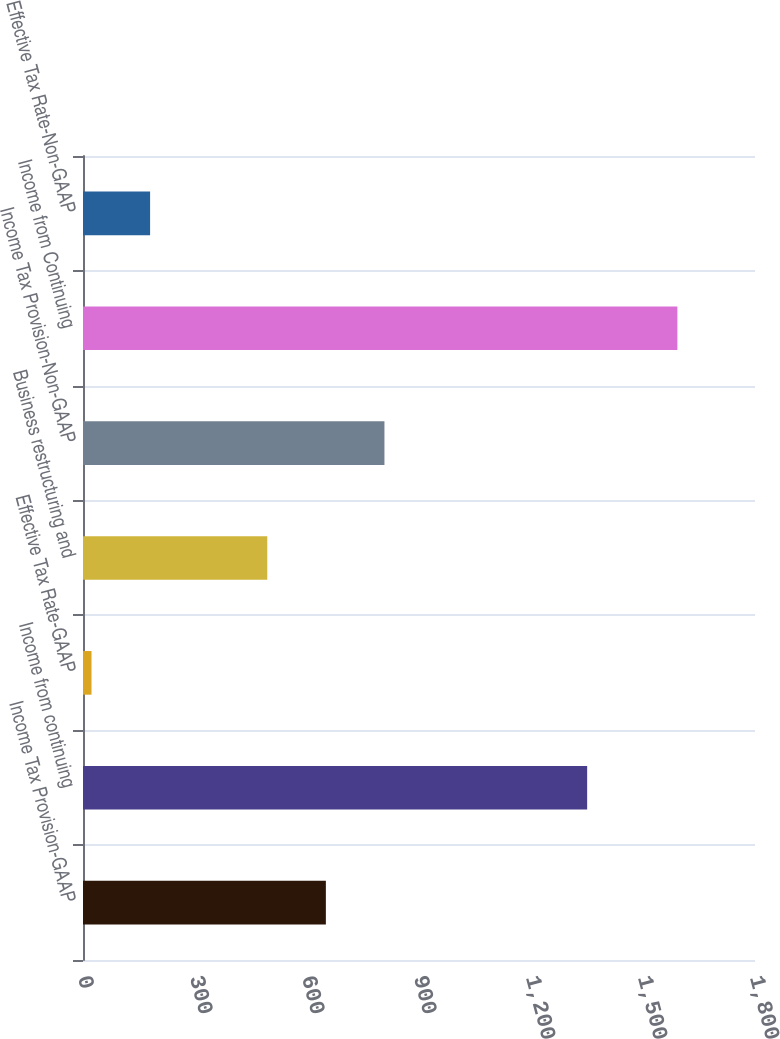<chart> <loc_0><loc_0><loc_500><loc_500><bar_chart><fcel>Income Tax Provision-GAAP<fcel>Income from continuing<fcel>Effective Tax Rate-GAAP<fcel>Business restructuring and<fcel>Income Tax Provision-Non-GAAP<fcel>Income from Continuing<fcel>Effective Tax Rate-Non-GAAP<nl><fcel>650.52<fcel>1350.4<fcel>22.8<fcel>493.59<fcel>807.45<fcel>1592.1<fcel>179.73<nl></chart> 